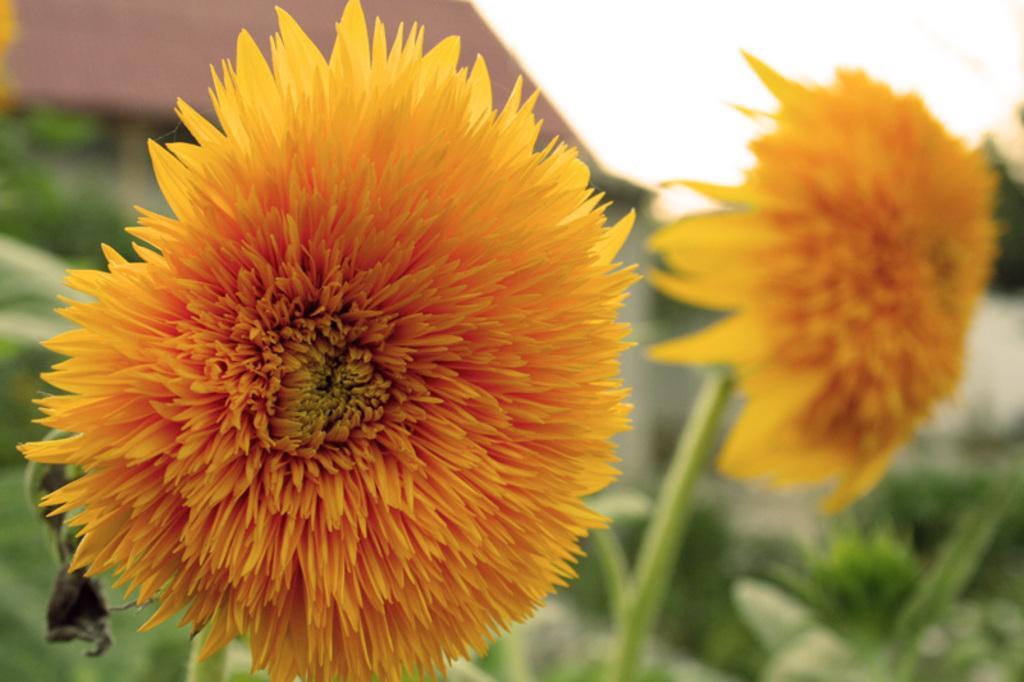In one or two sentences, can you explain what this image depicts? In this image we can see plants and flowers. At the top of the image there is sky. 